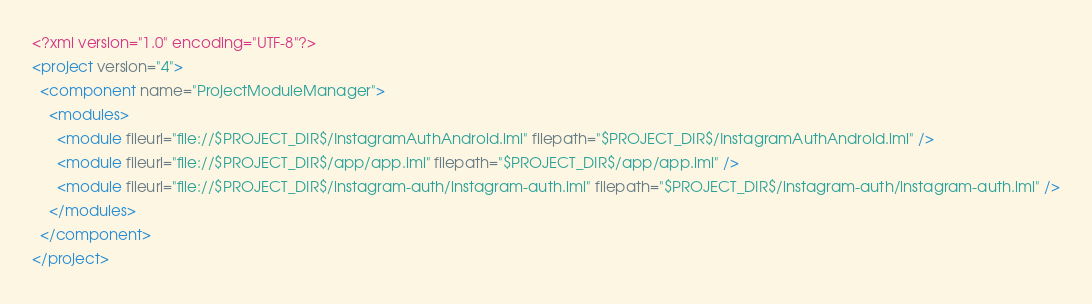<code> <loc_0><loc_0><loc_500><loc_500><_XML_><?xml version="1.0" encoding="UTF-8"?>
<project version="4">
  <component name="ProjectModuleManager">
    <modules>
      <module fileurl="file://$PROJECT_DIR$/InstagramAuthAndroid.iml" filepath="$PROJECT_DIR$/InstagramAuthAndroid.iml" />
      <module fileurl="file://$PROJECT_DIR$/app/app.iml" filepath="$PROJECT_DIR$/app/app.iml" />
      <module fileurl="file://$PROJECT_DIR$/instagram-auth/instagram-auth.iml" filepath="$PROJECT_DIR$/instagram-auth/instagram-auth.iml" />
    </modules>
  </component>
</project></code> 